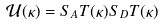Convert formula to latex. <formula><loc_0><loc_0><loc_500><loc_500>\mathcal { U } ( \kappa ) = S _ { A } T ( \kappa ) S _ { D } T ( \kappa )</formula> 